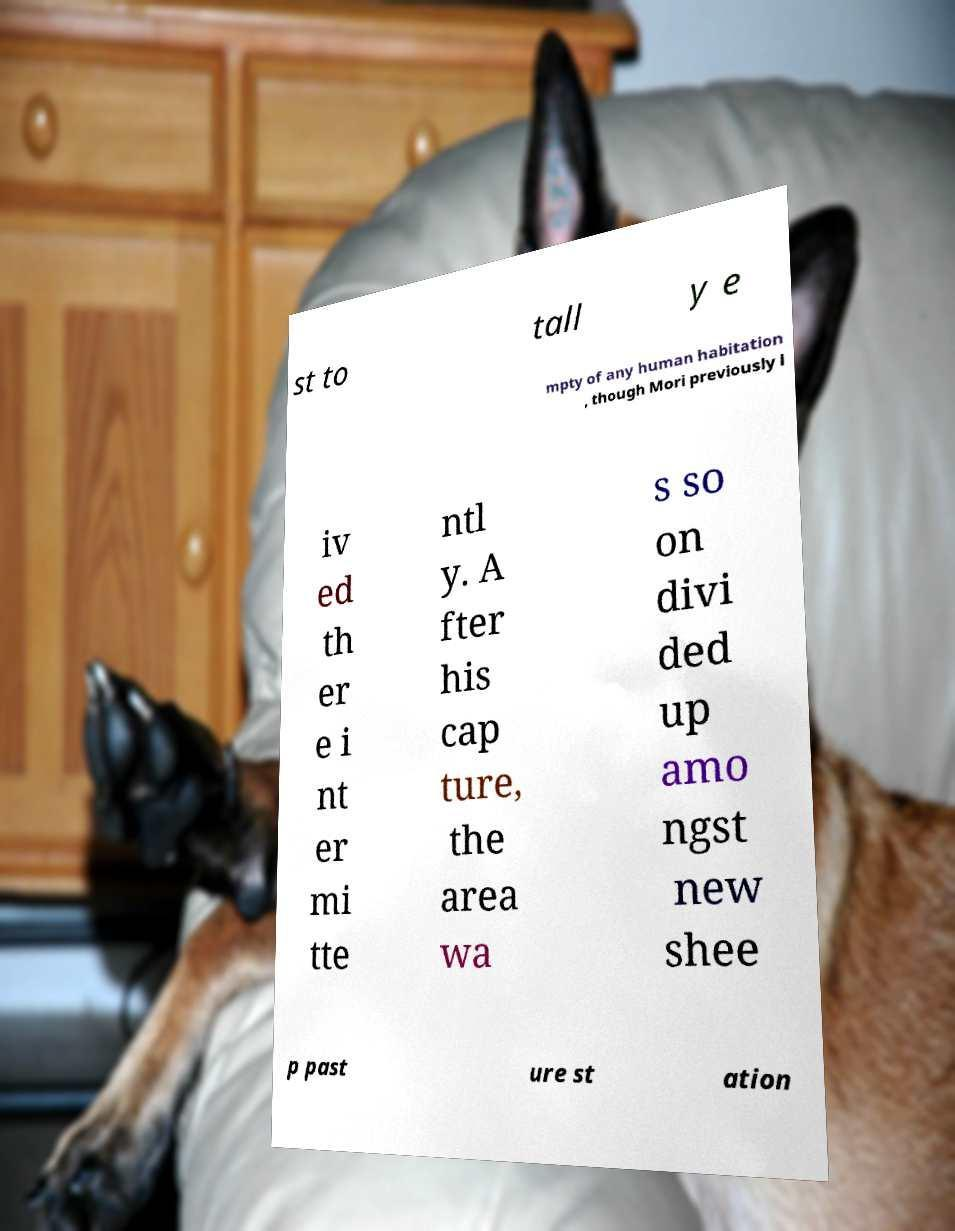Please read and relay the text visible in this image. What does it say? st to tall y e mpty of any human habitation , though Mori previously l iv ed th er e i nt er mi tte ntl y. A fter his cap ture, the area wa s so on divi ded up amo ngst new shee p past ure st ation 